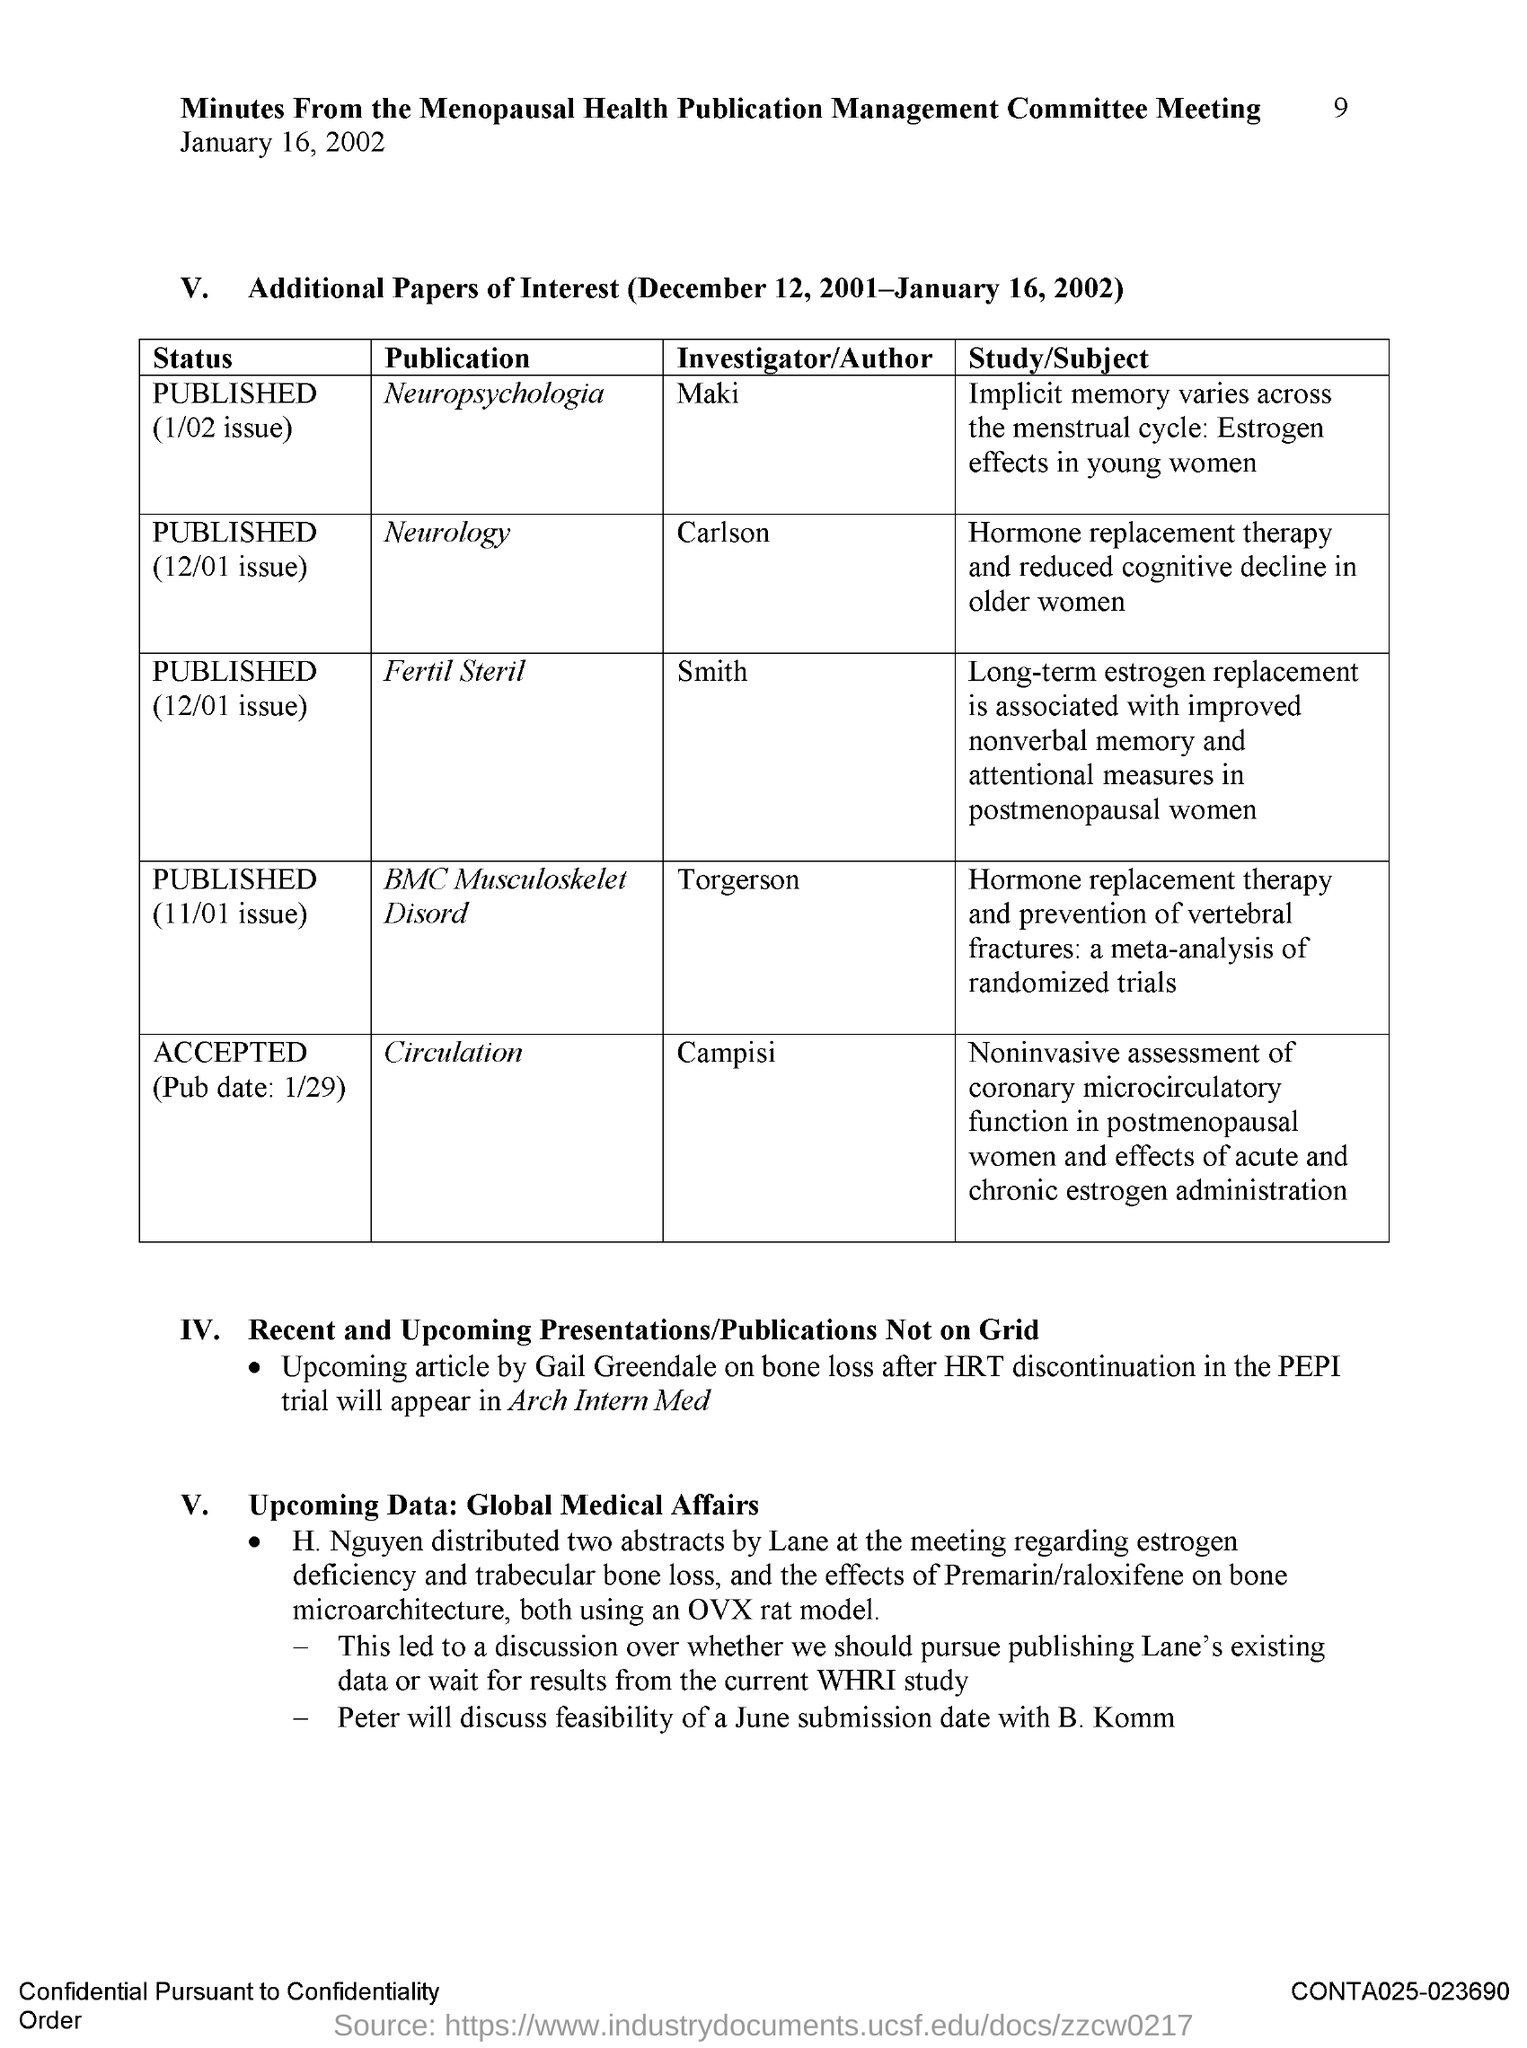Indicate a few pertinent items in this graphic. Carlson is the author of the publication "Neurology. The page number is 9. The publication "Circulation" was authored by Campisi. The author of the publication "Fertil Steril" is Smith. The publication "Neuropsychologia" is authored by Maki. 